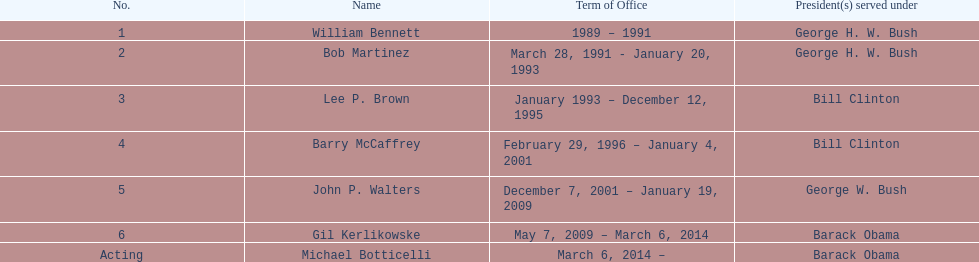How many years in total did bob martinez serve in office? 2. 